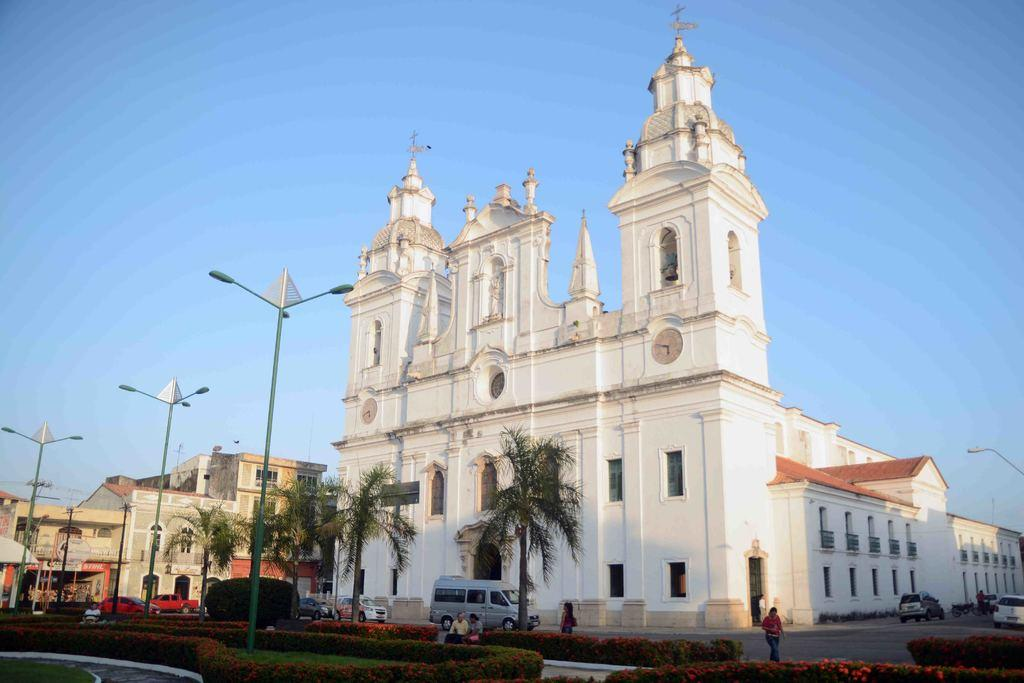What type of building is the main subject of the image? There is a church with windows in the image. Are there any other buildings visible in the image? Yes, there are other buildings in the image. What can be seen near the buildings? There are light poles in the image. What else is present in the image? There are vehicles and trees and bushes in the image. What is visible in the background of the image? The sky is visible in the background of the image. What type of expert advice is being given in the image? There is no expert or advice present in the image; it features a church and other buildings, light poles, vehicles, trees and bushes, and the sky. What type of board game is being played in the image? There is no board game or any indication of a game being played in the image. 